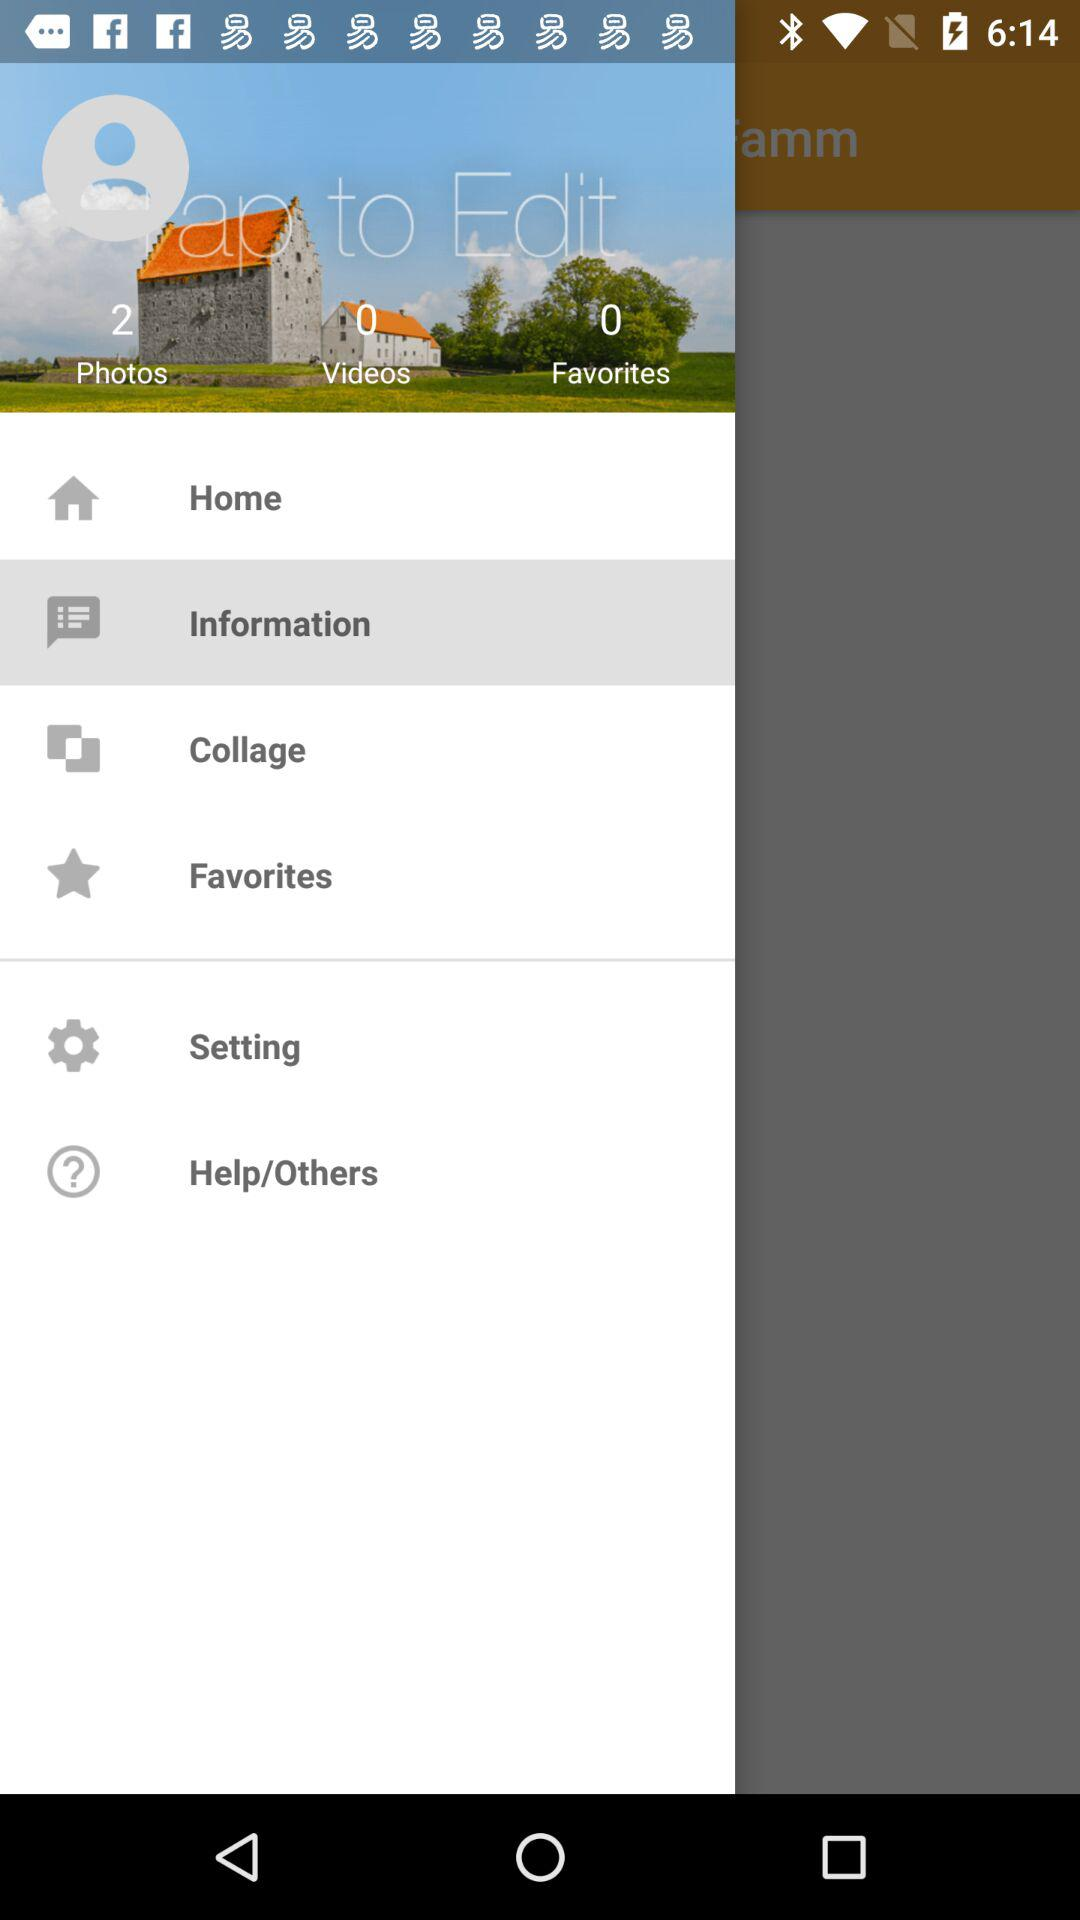How many photos are there? There are 2 photos. 